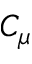<formula> <loc_0><loc_0><loc_500><loc_500>C _ { \mu }</formula> 